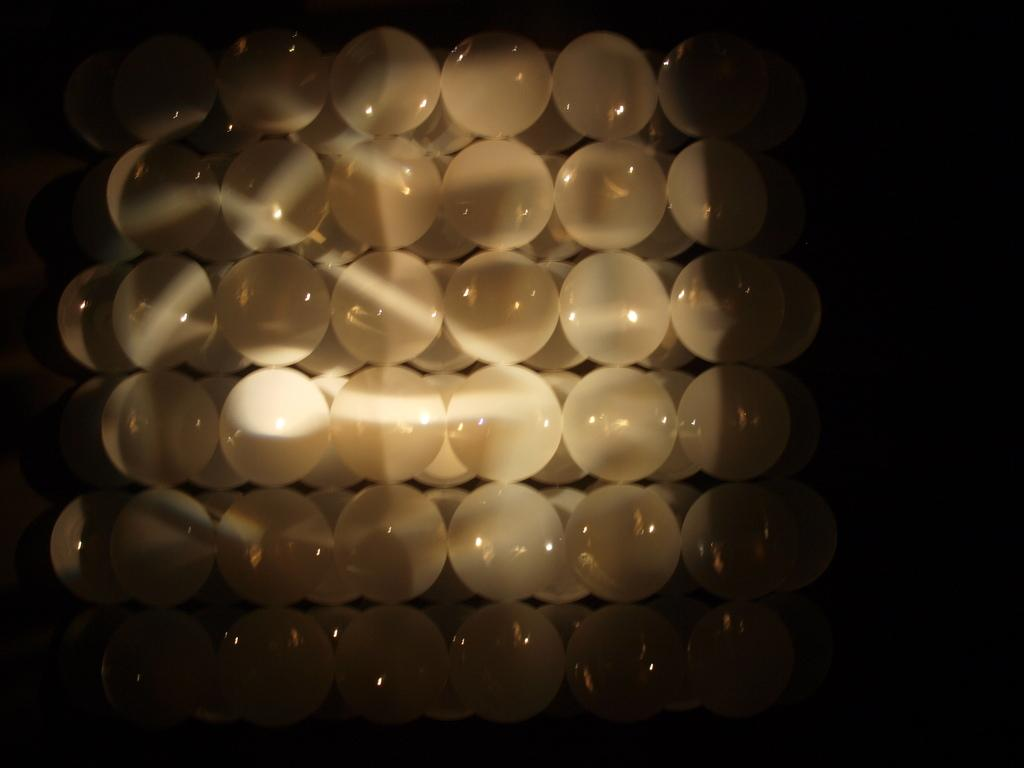What color are the balls in the image? The balls in the image are white. Can you see any cracks in the picture of the cellar in the image? There is no picture or cellar present in the image; it only contains white color balls. 